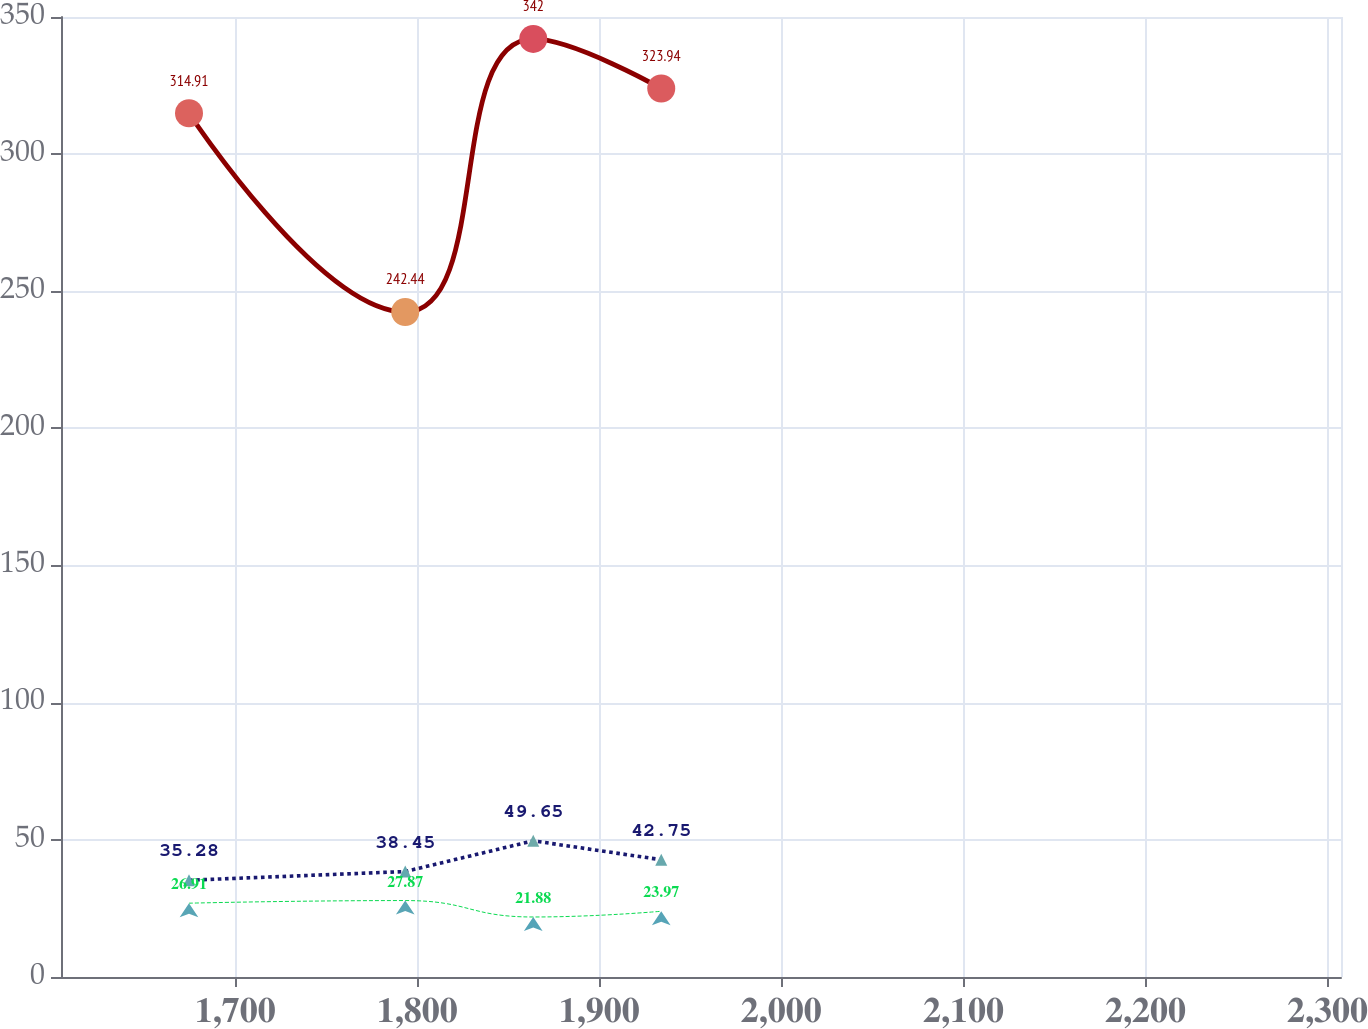Convert chart to OTSL. <chart><loc_0><loc_0><loc_500><loc_500><line_chart><ecel><fcel>Postretirement Health Care Benefits Plan<fcel>Non U.S. Pension Benefit Plans<fcel>U.S. Pension Benefit Plans<nl><fcel>1674.66<fcel>314.91<fcel>35.28<fcel>26.91<nl><fcel>1793.43<fcel>242.44<fcel>38.45<fcel>27.87<nl><fcel>1863.73<fcel>342<fcel>49.65<fcel>21.88<nl><fcel>1934.03<fcel>323.94<fcel>42.75<fcel>23.97<nl><fcel>2377.67<fcel>332.97<fcel>48.29<fcel>18.08<nl></chart> 